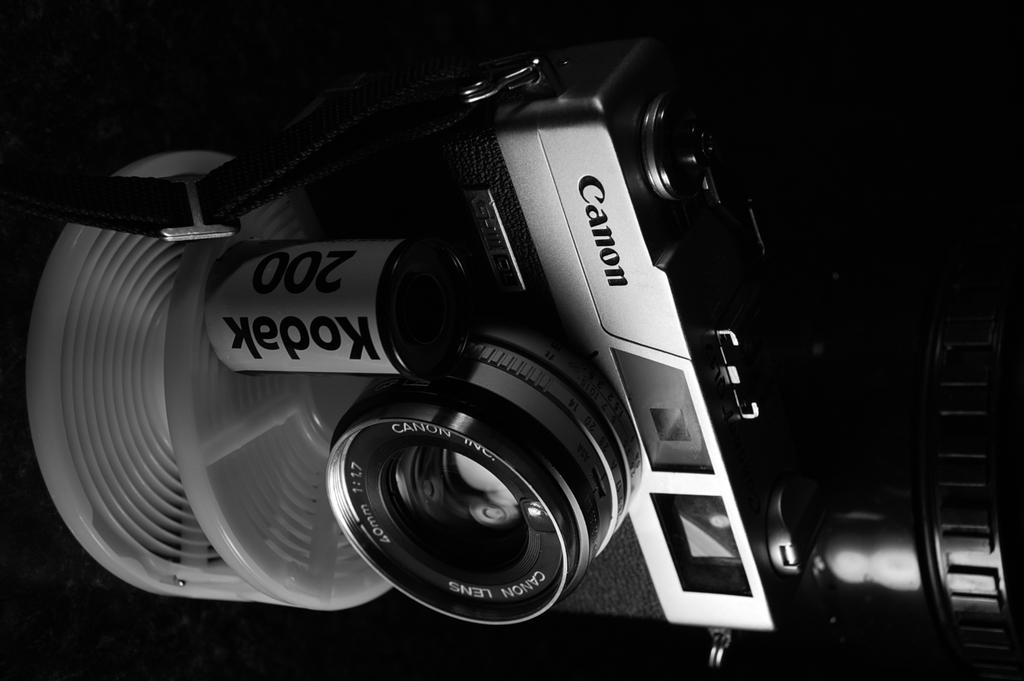What is the main object in the image? There is a camera in the image. What can be observed about the background of the image? The background of the image is dark. What type of liquid is being poured out of the camera in the image? There is no liquid being poured out of the camera in the image. How many parts of the camera can be seen in the image? The image only shows the camera as a whole, so it's not possible to determine the number of parts. 